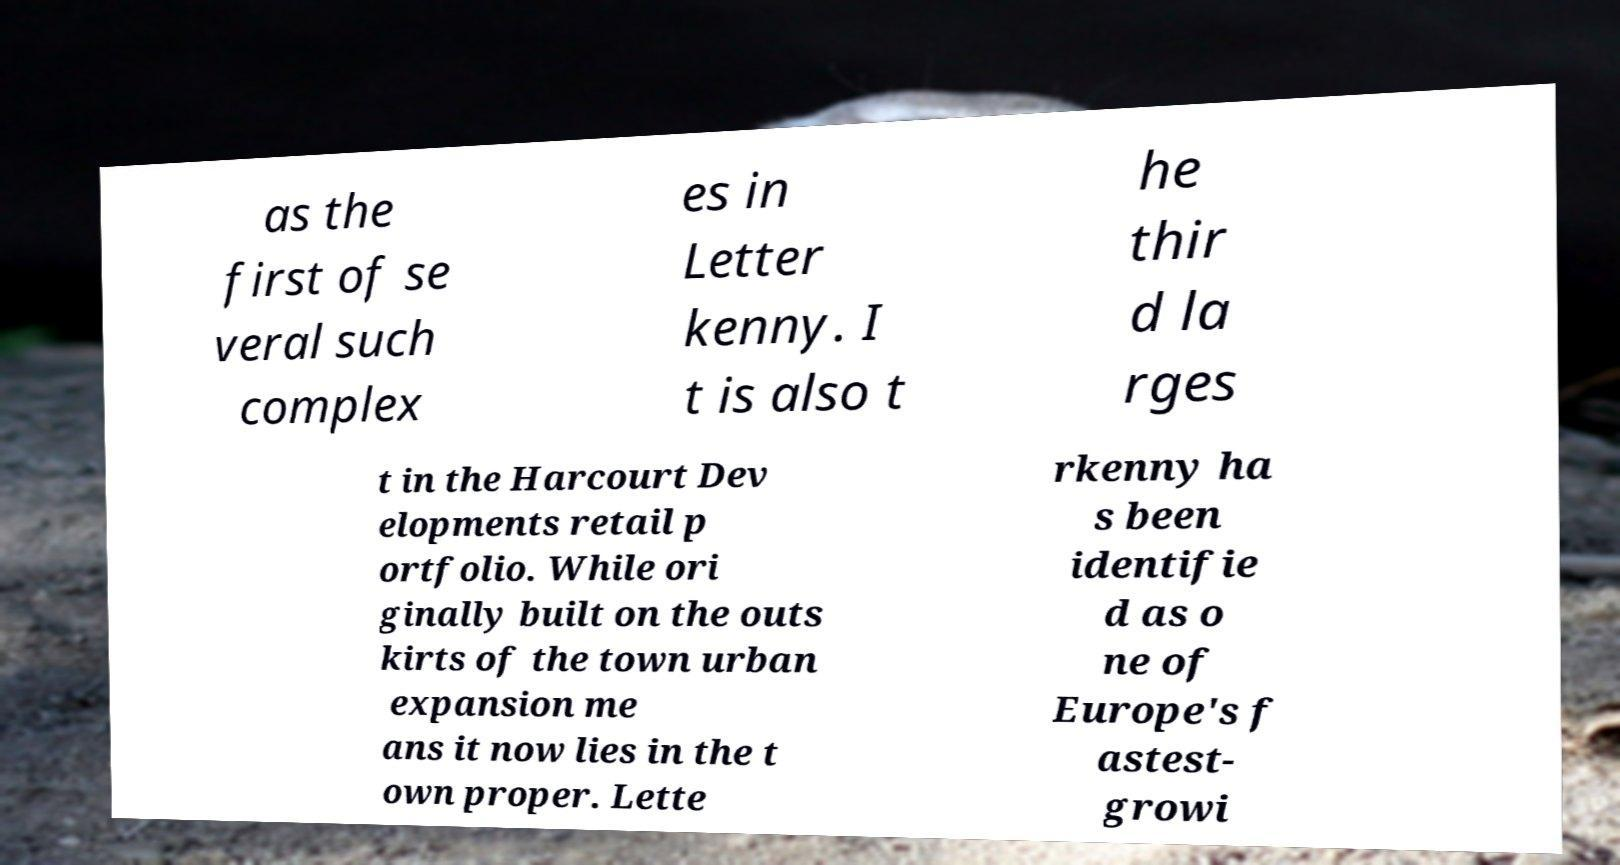What messages or text are displayed in this image? I need them in a readable, typed format. as the first of se veral such complex es in Letter kenny. I t is also t he thir d la rges t in the Harcourt Dev elopments retail p ortfolio. While ori ginally built on the outs kirts of the town urban expansion me ans it now lies in the t own proper. Lette rkenny ha s been identifie d as o ne of Europe's f astest- growi 